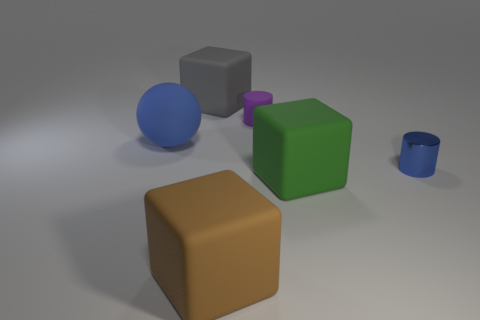Add 2 large rubber things. How many objects exist? 8 Subtract all cylinders. How many objects are left? 4 Subtract 1 green cubes. How many objects are left? 5 Subtract all big blue matte spheres. Subtract all red metallic cylinders. How many objects are left? 5 Add 2 small rubber objects. How many small rubber objects are left? 3 Add 3 big objects. How many big objects exist? 7 